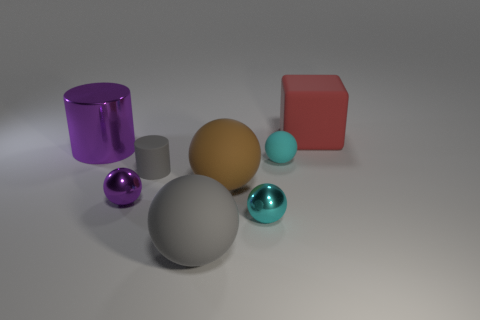There is a cyan thing that is in front of the small metallic object to the left of the small matte thing in front of the cyan rubber object; what is it made of?
Ensure brevity in your answer.  Metal. What is the material of the purple ball that is the same size as the gray matte cylinder?
Make the answer very short. Metal. Are there any objects behind the big gray matte thing?
Keep it short and to the point. Yes. There is a tiny cyan metallic object; is it the same shape as the large gray object to the right of the tiny gray cylinder?
Make the answer very short. Yes. What number of things are big objects right of the large purple cylinder or small yellow rubber objects?
Provide a succinct answer. 3. What number of objects are in front of the small purple ball and to the right of the large brown matte sphere?
Provide a short and direct response. 1. How many things are either rubber things in front of the tiny gray rubber thing or big objects left of the red thing?
Your response must be concise. 3. How many other objects are the same shape as the brown rubber thing?
Provide a short and direct response. 4. There is a metal object that is in front of the purple metallic sphere; is it the same color as the tiny matte sphere?
Make the answer very short. Yes. What number of other objects are there of the same size as the gray ball?
Provide a short and direct response. 3. 